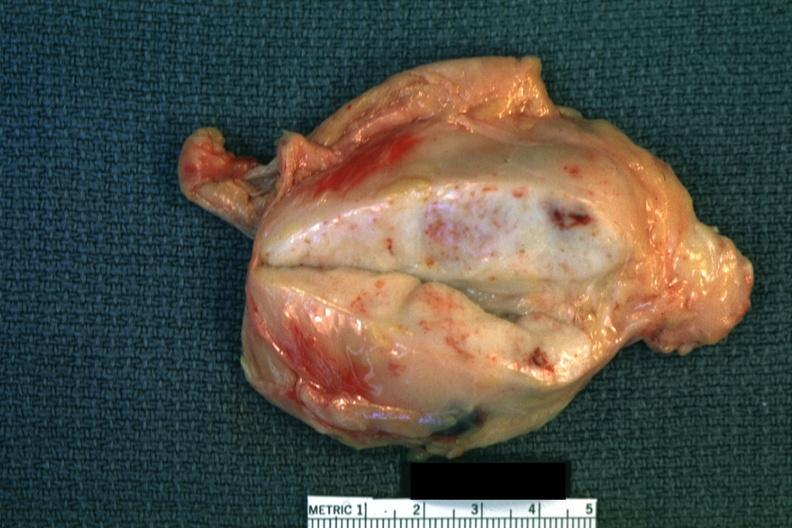s breast present?
Answer the question using a single word or phrase. No 